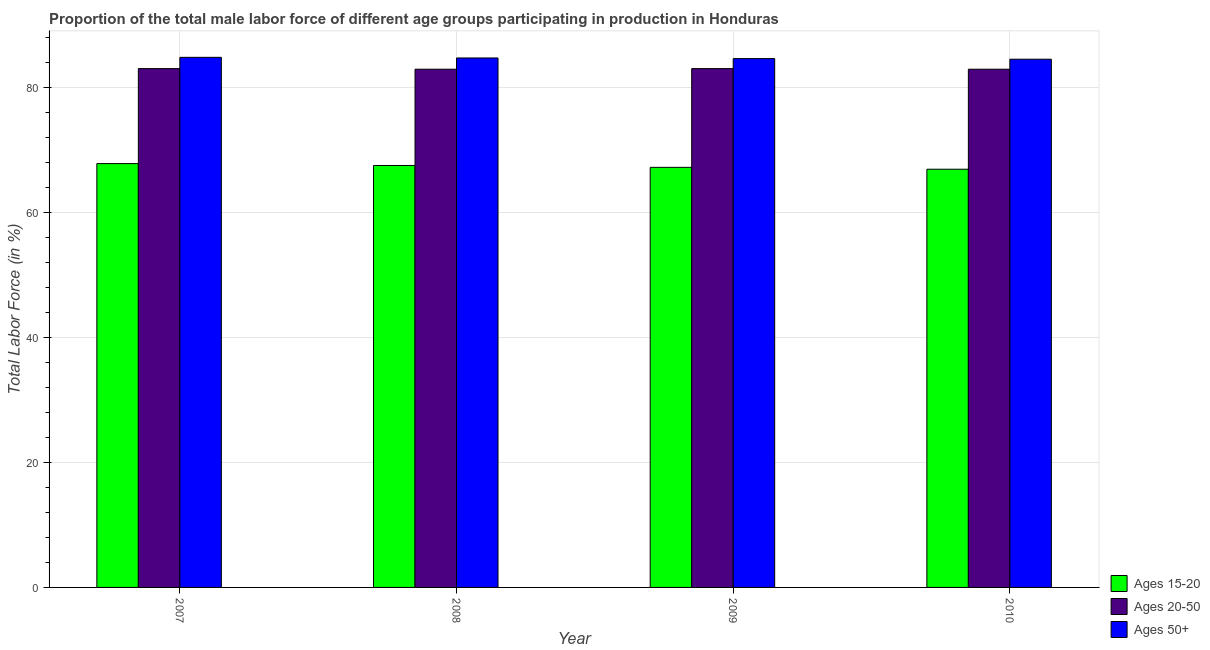Are the number of bars per tick equal to the number of legend labels?
Give a very brief answer. Yes. Are the number of bars on each tick of the X-axis equal?
Provide a succinct answer. Yes. How many bars are there on the 3rd tick from the left?
Offer a terse response. 3. How many bars are there on the 4th tick from the right?
Make the answer very short. 3. What is the label of the 2nd group of bars from the left?
Keep it short and to the point. 2008. In how many cases, is the number of bars for a given year not equal to the number of legend labels?
Offer a terse response. 0. What is the percentage of male labor force above age 50 in 2007?
Make the answer very short. 84.8. Across all years, what is the minimum percentage of male labor force within the age group 20-50?
Provide a short and direct response. 82.9. What is the total percentage of male labor force above age 50 in the graph?
Offer a very short reply. 338.6. What is the difference between the percentage of male labor force above age 50 in 2009 and that in 2010?
Your answer should be compact. 0.1. What is the difference between the percentage of male labor force above age 50 in 2008 and the percentage of male labor force within the age group 15-20 in 2009?
Offer a very short reply. 0.1. What is the average percentage of male labor force within the age group 15-20 per year?
Give a very brief answer. 67.35. In the year 2010, what is the difference between the percentage of male labor force within the age group 15-20 and percentage of male labor force within the age group 20-50?
Make the answer very short. 0. In how many years, is the percentage of male labor force within the age group 15-20 greater than 72 %?
Your answer should be very brief. 0. What is the ratio of the percentage of male labor force within the age group 15-20 in 2007 to that in 2010?
Provide a short and direct response. 1.01. Is the difference between the percentage of male labor force above age 50 in 2009 and 2010 greater than the difference between the percentage of male labor force within the age group 15-20 in 2009 and 2010?
Keep it short and to the point. No. What is the difference between the highest and the second highest percentage of male labor force above age 50?
Make the answer very short. 0.1. What is the difference between the highest and the lowest percentage of male labor force within the age group 15-20?
Your answer should be very brief. 0.9. In how many years, is the percentage of male labor force above age 50 greater than the average percentage of male labor force above age 50 taken over all years?
Provide a succinct answer. 2. Is the sum of the percentage of male labor force within the age group 20-50 in 2007 and 2009 greater than the maximum percentage of male labor force above age 50 across all years?
Give a very brief answer. Yes. What does the 3rd bar from the left in 2007 represents?
Make the answer very short. Ages 50+. What does the 2nd bar from the right in 2010 represents?
Ensure brevity in your answer.  Ages 20-50. Is it the case that in every year, the sum of the percentage of male labor force within the age group 15-20 and percentage of male labor force within the age group 20-50 is greater than the percentage of male labor force above age 50?
Ensure brevity in your answer.  Yes. How many bars are there?
Provide a succinct answer. 12. Are all the bars in the graph horizontal?
Your answer should be very brief. No. How many years are there in the graph?
Offer a very short reply. 4. What is the difference between two consecutive major ticks on the Y-axis?
Offer a terse response. 20. Where does the legend appear in the graph?
Ensure brevity in your answer.  Bottom right. How are the legend labels stacked?
Your response must be concise. Vertical. What is the title of the graph?
Keep it short and to the point. Proportion of the total male labor force of different age groups participating in production in Honduras. What is the label or title of the Y-axis?
Offer a very short reply. Total Labor Force (in %). What is the Total Labor Force (in %) in Ages 15-20 in 2007?
Provide a short and direct response. 67.8. What is the Total Labor Force (in %) of Ages 20-50 in 2007?
Keep it short and to the point. 83. What is the Total Labor Force (in %) of Ages 50+ in 2007?
Ensure brevity in your answer.  84.8. What is the Total Labor Force (in %) in Ages 15-20 in 2008?
Offer a terse response. 67.5. What is the Total Labor Force (in %) in Ages 20-50 in 2008?
Offer a very short reply. 82.9. What is the Total Labor Force (in %) of Ages 50+ in 2008?
Your response must be concise. 84.7. What is the Total Labor Force (in %) in Ages 15-20 in 2009?
Make the answer very short. 67.2. What is the Total Labor Force (in %) in Ages 50+ in 2009?
Provide a short and direct response. 84.6. What is the Total Labor Force (in %) of Ages 15-20 in 2010?
Ensure brevity in your answer.  66.9. What is the Total Labor Force (in %) of Ages 20-50 in 2010?
Your answer should be very brief. 82.9. What is the Total Labor Force (in %) of Ages 50+ in 2010?
Ensure brevity in your answer.  84.5. Across all years, what is the maximum Total Labor Force (in %) in Ages 15-20?
Provide a succinct answer. 67.8. Across all years, what is the maximum Total Labor Force (in %) in Ages 50+?
Offer a terse response. 84.8. Across all years, what is the minimum Total Labor Force (in %) in Ages 15-20?
Your answer should be very brief. 66.9. Across all years, what is the minimum Total Labor Force (in %) of Ages 20-50?
Provide a succinct answer. 82.9. Across all years, what is the minimum Total Labor Force (in %) of Ages 50+?
Make the answer very short. 84.5. What is the total Total Labor Force (in %) of Ages 15-20 in the graph?
Give a very brief answer. 269.4. What is the total Total Labor Force (in %) in Ages 20-50 in the graph?
Offer a terse response. 331.8. What is the total Total Labor Force (in %) of Ages 50+ in the graph?
Your response must be concise. 338.6. What is the difference between the Total Labor Force (in %) in Ages 15-20 in 2007 and that in 2009?
Your answer should be compact. 0.6. What is the difference between the Total Labor Force (in %) of Ages 15-20 in 2007 and that in 2010?
Your answer should be compact. 0.9. What is the difference between the Total Labor Force (in %) of Ages 20-50 in 2007 and that in 2010?
Offer a terse response. 0.1. What is the difference between the Total Labor Force (in %) of Ages 50+ in 2008 and that in 2009?
Provide a succinct answer. 0.1. What is the difference between the Total Labor Force (in %) in Ages 15-20 in 2008 and that in 2010?
Offer a very short reply. 0.6. What is the difference between the Total Labor Force (in %) in Ages 50+ in 2009 and that in 2010?
Offer a very short reply. 0.1. What is the difference between the Total Labor Force (in %) in Ages 15-20 in 2007 and the Total Labor Force (in %) in Ages 20-50 in 2008?
Offer a terse response. -15.1. What is the difference between the Total Labor Force (in %) of Ages 15-20 in 2007 and the Total Labor Force (in %) of Ages 50+ in 2008?
Make the answer very short. -16.9. What is the difference between the Total Labor Force (in %) in Ages 15-20 in 2007 and the Total Labor Force (in %) in Ages 20-50 in 2009?
Your answer should be compact. -15.2. What is the difference between the Total Labor Force (in %) in Ages 15-20 in 2007 and the Total Labor Force (in %) in Ages 50+ in 2009?
Keep it short and to the point. -16.8. What is the difference between the Total Labor Force (in %) of Ages 20-50 in 2007 and the Total Labor Force (in %) of Ages 50+ in 2009?
Make the answer very short. -1.6. What is the difference between the Total Labor Force (in %) of Ages 15-20 in 2007 and the Total Labor Force (in %) of Ages 20-50 in 2010?
Keep it short and to the point. -15.1. What is the difference between the Total Labor Force (in %) in Ages 15-20 in 2007 and the Total Labor Force (in %) in Ages 50+ in 2010?
Offer a very short reply. -16.7. What is the difference between the Total Labor Force (in %) of Ages 15-20 in 2008 and the Total Labor Force (in %) of Ages 20-50 in 2009?
Your answer should be very brief. -15.5. What is the difference between the Total Labor Force (in %) in Ages 15-20 in 2008 and the Total Labor Force (in %) in Ages 50+ in 2009?
Ensure brevity in your answer.  -17.1. What is the difference between the Total Labor Force (in %) of Ages 20-50 in 2008 and the Total Labor Force (in %) of Ages 50+ in 2009?
Offer a very short reply. -1.7. What is the difference between the Total Labor Force (in %) in Ages 15-20 in 2008 and the Total Labor Force (in %) in Ages 20-50 in 2010?
Keep it short and to the point. -15.4. What is the difference between the Total Labor Force (in %) of Ages 20-50 in 2008 and the Total Labor Force (in %) of Ages 50+ in 2010?
Your response must be concise. -1.6. What is the difference between the Total Labor Force (in %) in Ages 15-20 in 2009 and the Total Labor Force (in %) in Ages 20-50 in 2010?
Your answer should be compact. -15.7. What is the difference between the Total Labor Force (in %) of Ages 15-20 in 2009 and the Total Labor Force (in %) of Ages 50+ in 2010?
Offer a very short reply. -17.3. What is the difference between the Total Labor Force (in %) of Ages 20-50 in 2009 and the Total Labor Force (in %) of Ages 50+ in 2010?
Your answer should be very brief. -1.5. What is the average Total Labor Force (in %) in Ages 15-20 per year?
Ensure brevity in your answer.  67.35. What is the average Total Labor Force (in %) of Ages 20-50 per year?
Your answer should be very brief. 82.95. What is the average Total Labor Force (in %) of Ages 50+ per year?
Your answer should be compact. 84.65. In the year 2007, what is the difference between the Total Labor Force (in %) of Ages 15-20 and Total Labor Force (in %) of Ages 20-50?
Your answer should be compact. -15.2. In the year 2007, what is the difference between the Total Labor Force (in %) of Ages 15-20 and Total Labor Force (in %) of Ages 50+?
Offer a terse response. -17. In the year 2008, what is the difference between the Total Labor Force (in %) in Ages 15-20 and Total Labor Force (in %) in Ages 20-50?
Provide a succinct answer. -15.4. In the year 2008, what is the difference between the Total Labor Force (in %) in Ages 15-20 and Total Labor Force (in %) in Ages 50+?
Your answer should be compact. -17.2. In the year 2009, what is the difference between the Total Labor Force (in %) of Ages 15-20 and Total Labor Force (in %) of Ages 20-50?
Offer a very short reply. -15.8. In the year 2009, what is the difference between the Total Labor Force (in %) of Ages 15-20 and Total Labor Force (in %) of Ages 50+?
Give a very brief answer. -17.4. In the year 2010, what is the difference between the Total Labor Force (in %) of Ages 15-20 and Total Labor Force (in %) of Ages 20-50?
Keep it short and to the point. -16. In the year 2010, what is the difference between the Total Labor Force (in %) of Ages 15-20 and Total Labor Force (in %) of Ages 50+?
Your answer should be very brief. -17.6. In the year 2010, what is the difference between the Total Labor Force (in %) in Ages 20-50 and Total Labor Force (in %) in Ages 50+?
Your answer should be compact. -1.6. What is the ratio of the Total Labor Force (in %) of Ages 15-20 in 2007 to that in 2008?
Provide a succinct answer. 1. What is the ratio of the Total Labor Force (in %) in Ages 20-50 in 2007 to that in 2008?
Offer a very short reply. 1. What is the ratio of the Total Labor Force (in %) in Ages 50+ in 2007 to that in 2008?
Give a very brief answer. 1. What is the ratio of the Total Labor Force (in %) in Ages 15-20 in 2007 to that in 2009?
Make the answer very short. 1.01. What is the ratio of the Total Labor Force (in %) in Ages 20-50 in 2007 to that in 2009?
Provide a succinct answer. 1. What is the ratio of the Total Labor Force (in %) of Ages 50+ in 2007 to that in 2009?
Your answer should be compact. 1. What is the ratio of the Total Labor Force (in %) of Ages 15-20 in 2007 to that in 2010?
Offer a terse response. 1.01. What is the ratio of the Total Labor Force (in %) of Ages 20-50 in 2007 to that in 2010?
Offer a terse response. 1. What is the ratio of the Total Labor Force (in %) of Ages 50+ in 2007 to that in 2010?
Keep it short and to the point. 1. What is the ratio of the Total Labor Force (in %) of Ages 15-20 in 2008 to that in 2010?
Offer a very short reply. 1.01. What is the ratio of the Total Labor Force (in %) in Ages 20-50 in 2008 to that in 2010?
Give a very brief answer. 1. What is the difference between the highest and the second highest Total Labor Force (in %) of Ages 15-20?
Make the answer very short. 0.3. What is the difference between the highest and the second highest Total Labor Force (in %) in Ages 20-50?
Make the answer very short. 0. What is the difference between the highest and the second highest Total Labor Force (in %) of Ages 50+?
Keep it short and to the point. 0.1. What is the difference between the highest and the lowest Total Labor Force (in %) of Ages 50+?
Ensure brevity in your answer.  0.3. 